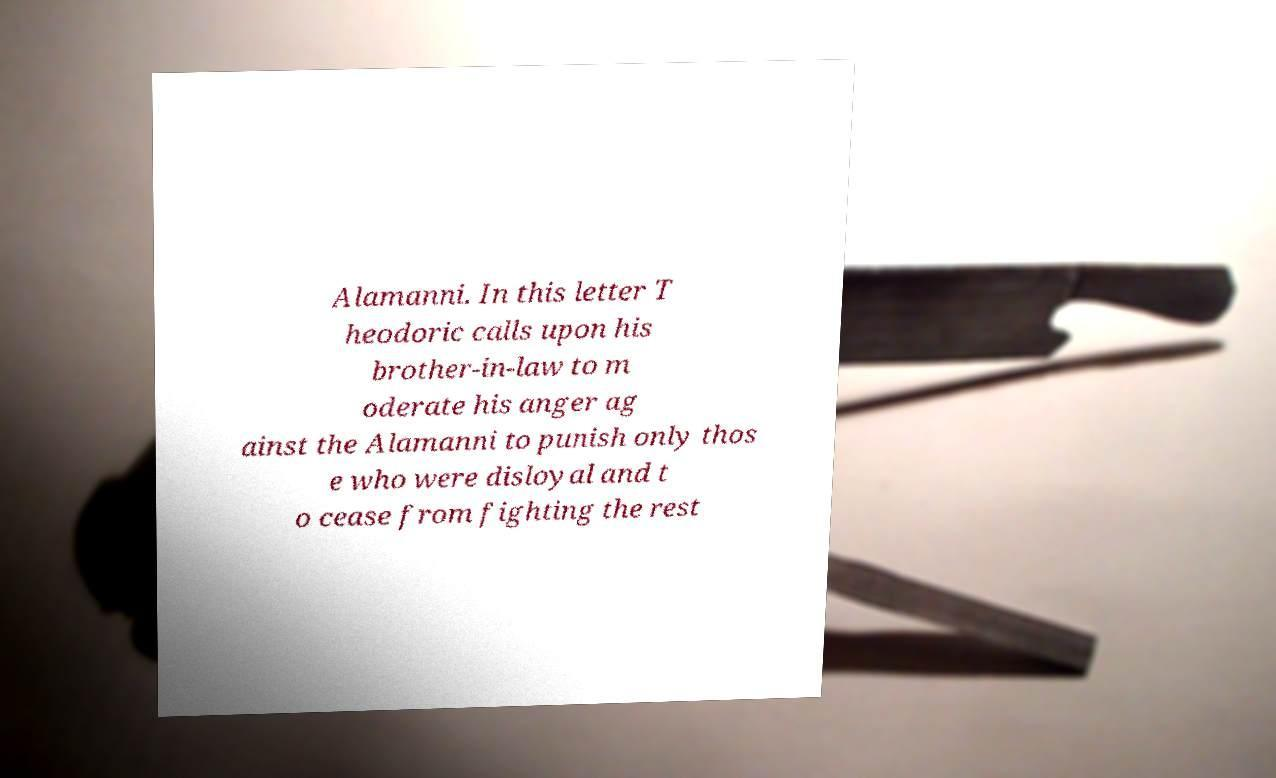Can you accurately transcribe the text from the provided image for me? Alamanni. In this letter T heodoric calls upon his brother-in-law to m oderate his anger ag ainst the Alamanni to punish only thos e who were disloyal and t o cease from fighting the rest 